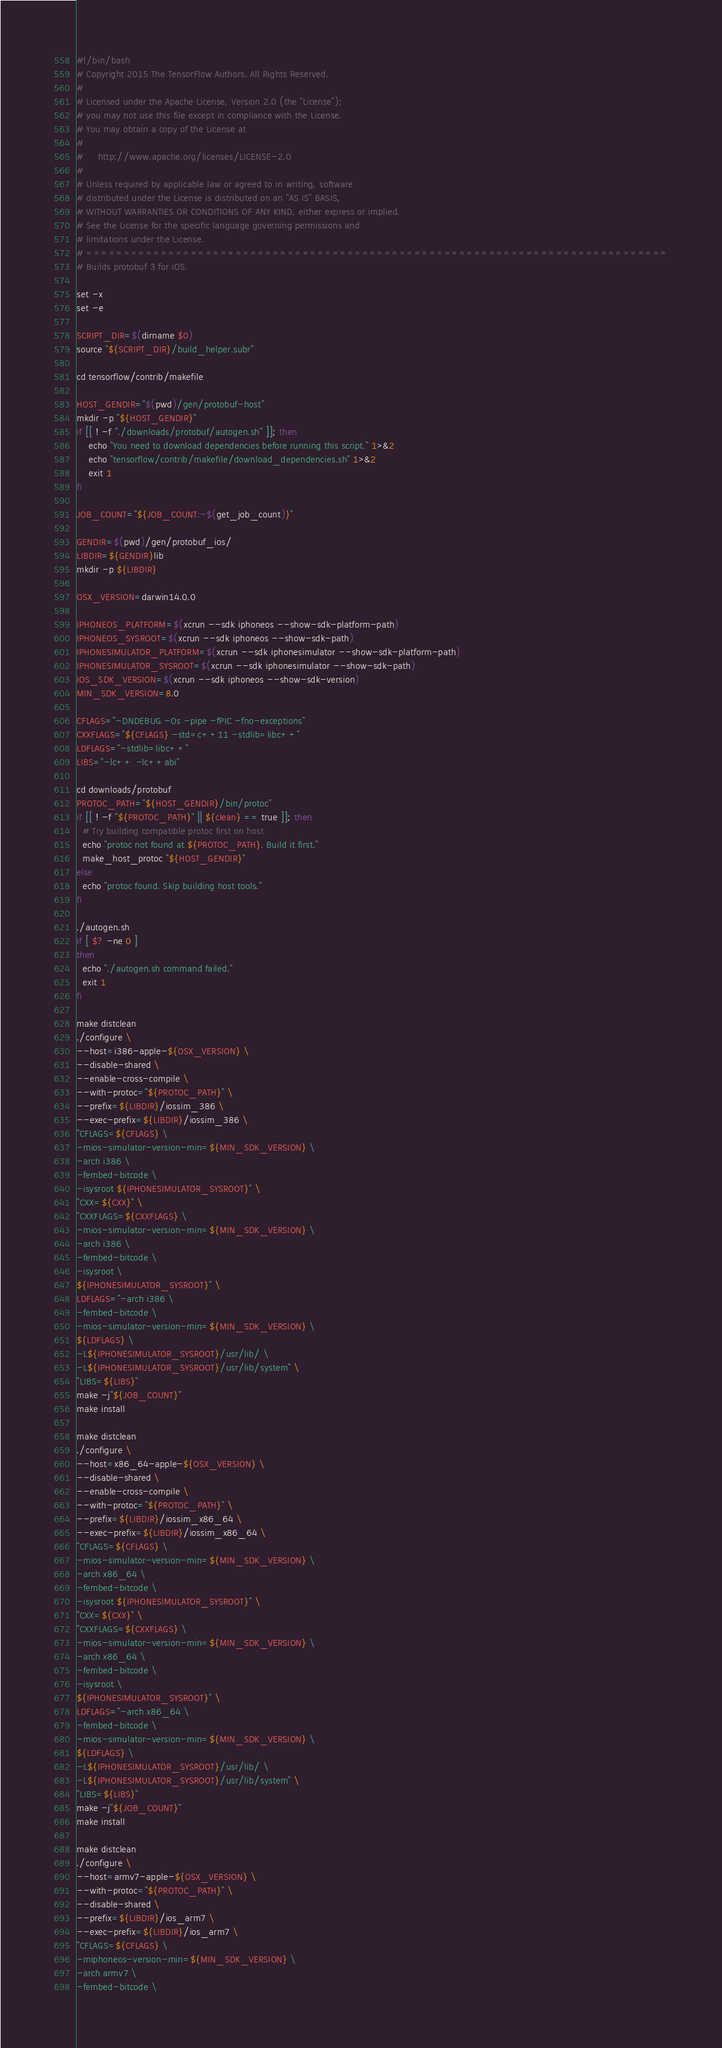Convert code to text. <code><loc_0><loc_0><loc_500><loc_500><_Bash_>#!/bin/bash
# Copyright 2015 The TensorFlow Authors. All Rights Reserved.
#
# Licensed under the Apache License, Version 2.0 (the "License");
# you may not use this file except in compliance with the License.
# You may obtain a copy of the License at
#
#     http://www.apache.org/licenses/LICENSE-2.0
#
# Unless required by applicable law or agreed to in writing, software
# distributed under the License is distributed on an "AS IS" BASIS,
# WITHOUT WARRANTIES OR CONDITIONS OF ANY KIND, either express or implied.
# See the License for the specific language governing permissions and
# limitations under the License.
# ==============================================================================
# Builds protobuf 3 for iOS.

set -x
set -e

SCRIPT_DIR=$(dirname $0)
source "${SCRIPT_DIR}/build_helper.subr"

cd tensorflow/contrib/makefile

HOST_GENDIR="$(pwd)/gen/protobuf-host"
mkdir -p "${HOST_GENDIR}"
if [[ ! -f "./downloads/protobuf/autogen.sh" ]]; then
    echo "You need to download dependencies before running this script." 1>&2
    echo "tensorflow/contrib/makefile/download_dependencies.sh" 1>&2
    exit 1
fi

JOB_COUNT="${JOB_COUNT:-$(get_job_count)}"

GENDIR=$(pwd)/gen/protobuf_ios/
LIBDIR=${GENDIR}lib
mkdir -p ${LIBDIR}

OSX_VERSION=darwin14.0.0

IPHONEOS_PLATFORM=$(xcrun --sdk iphoneos --show-sdk-platform-path)
IPHONEOS_SYSROOT=$(xcrun --sdk iphoneos --show-sdk-path)
IPHONESIMULATOR_PLATFORM=$(xcrun --sdk iphonesimulator --show-sdk-platform-path)
IPHONESIMULATOR_SYSROOT=$(xcrun --sdk iphonesimulator --show-sdk-path)
IOS_SDK_VERSION=$(xcrun --sdk iphoneos --show-sdk-version)
MIN_SDK_VERSION=8.0

CFLAGS="-DNDEBUG -Os -pipe -fPIC -fno-exceptions"
CXXFLAGS="${CFLAGS} -std=c++11 -stdlib=libc++"
LDFLAGS="-stdlib=libc++"
LIBS="-lc++ -lc++abi"

cd downloads/protobuf
PROTOC_PATH="${HOST_GENDIR}/bin/protoc"
if [[ ! -f "${PROTOC_PATH}" || ${clean} == true ]]; then
  # Try building compatible protoc first on host
  echo "protoc not found at ${PROTOC_PATH}. Build it first."
  make_host_protoc "${HOST_GENDIR}"
else
  echo "protoc found. Skip building host tools."
fi

./autogen.sh
if [ $? -ne 0 ]
then
  echo "./autogen.sh command failed."
  exit 1
fi

make distclean
./configure \
--host=i386-apple-${OSX_VERSION} \
--disable-shared \
--enable-cross-compile \
--with-protoc="${PROTOC_PATH}" \
--prefix=${LIBDIR}/iossim_386 \
--exec-prefix=${LIBDIR}/iossim_386 \
"CFLAGS=${CFLAGS} \
-mios-simulator-version-min=${MIN_SDK_VERSION} \
-arch i386 \
-fembed-bitcode \
-isysroot ${IPHONESIMULATOR_SYSROOT}" \
"CXX=${CXX}" \
"CXXFLAGS=${CXXFLAGS} \
-mios-simulator-version-min=${MIN_SDK_VERSION} \
-arch i386 \
-fembed-bitcode \
-isysroot \
${IPHONESIMULATOR_SYSROOT}" \
LDFLAGS="-arch i386 \
-fembed-bitcode \
-mios-simulator-version-min=${MIN_SDK_VERSION} \
${LDFLAGS} \
-L${IPHONESIMULATOR_SYSROOT}/usr/lib/ \
-L${IPHONESIMULATOR_SYSROOT}/usr/lib/system" \
"LIBS=${LIBS}"
make -j"${JOB_COUNT}"
make install

make distclean
./configure \
--host=x86_64-apple-${OSX_VERSION} \
--disable-shared \
--enable-cross-compile \
--with-protoc="${PROTOC_PATH}" \
--prefix=${LIBDIR}/iossim_x86_64 \
--exec-prefix=${LIBDIR}/iossim_x86_64 \
"CFLAGS=${CFLAGS} \
-mios-simulator-version-min=${MIN_SDK_VERSION} \
-arch x86_64 \
-fembed-bitcode \
-isysroot ${IPHONESIMULATOR_SYSROOT}" \
"CXX=${CXX}" \
"CXXFLAGS=${CXXFLAGS} \
-mios-simulator-version-min=${MIN_SDK_VERSION} \
-arch x86_64 \
-fembed-bitcode \
-isysroot \
${IPHONESIMULATOR_SYSROOT}" \
LDFLAGS="-arch x86_64 \
-fembed-bitcode \
-mios-simulator-version-min=${MIN_SDK_VERSION} \
${LDFLAGS} \
-L${IPHONESIMULATOR_SYSROOT}/usr/lib/ \
-L${IPHONESIMULATOR_SYSROOT}/usr/lib/system" \
"LIBS=${LIBS}"
make -j"${JOB_COUNT}"
make install

make distclean
./configure \
--host=armv7-apple-${OSX_VERSION} \
--with-protoc="${PROTOC_PATH}" \
--disable-shared \
--prefix=${LIBDIR}/ios_arm7 \
--exec-prefix=${LIBDIR}/ios_arm7 \
"CFLAGS=${CFLAGS} \
-miphoneos-version-min=${MIN_SDK_VERSION} \
-arch armv7 \
-fembed-bitcode \</code> 